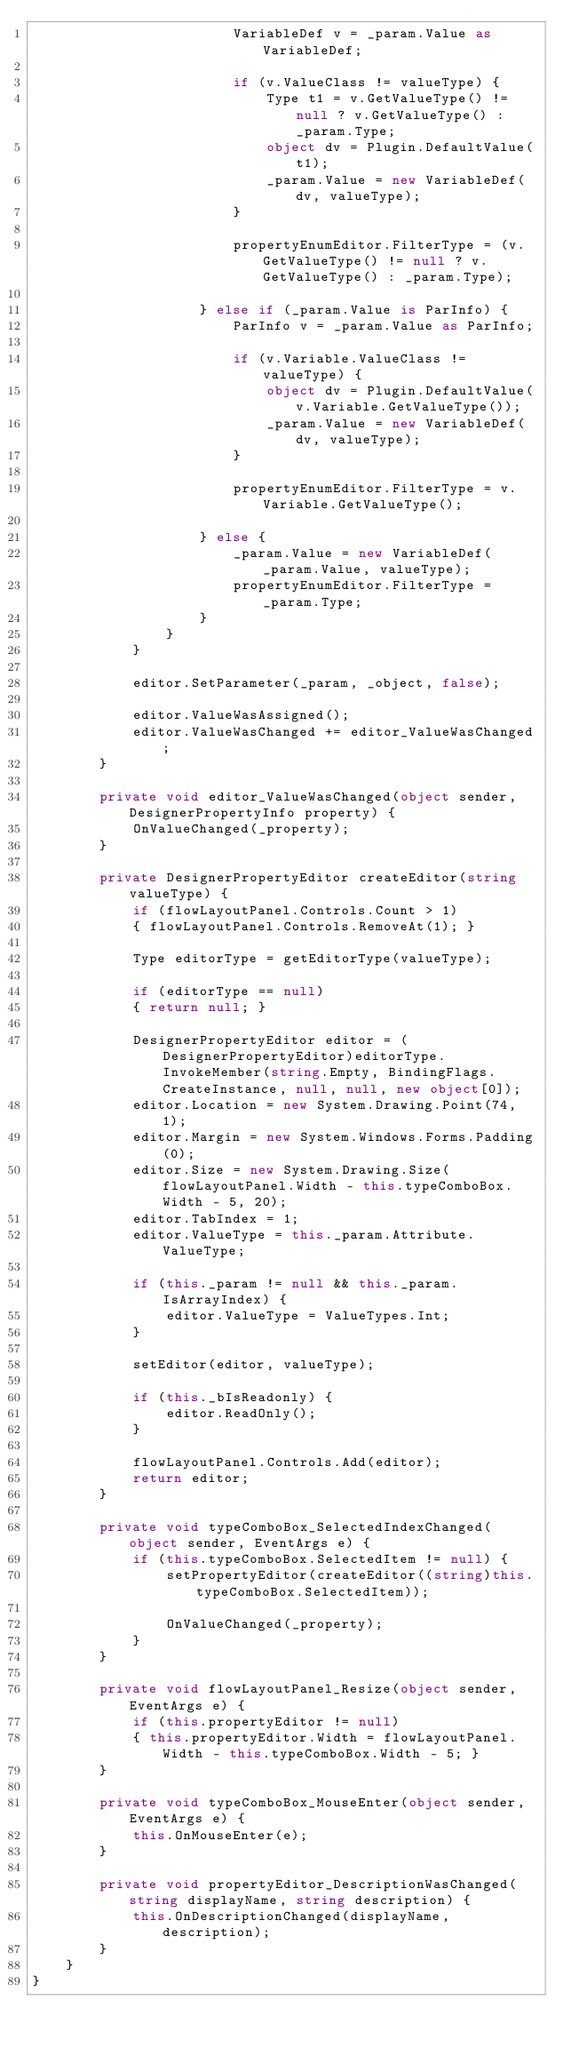<code> <loc_0><loc_0><loc_500><loc_500><_C#_>                        VariableDef v = _param.Value as VariableDef;

                        if (v.ValueClass != valueType) {
                            Type t1 = v.GetValueType() != null ? v.GetValueType() : _param.Type;
                            object dv = Plugin.DefaultValue(t1);
                            _param.Value = new VariableDef(dv, valueType);
                        }

                        propertyEnumEditor.FilterType = (v.GetValueType() != null ? v.GetValueType() : _param.Type);

                    } else if (_param.Value is ParInfo) {
                        ParInfo v = _param.Value as ParInfo;

                        if (v.Variable.ValueClass != valueType) {
                            object dv = Plugin.DefaultValue(v.Variable.GetValueType());
                            _param.Value = new VariableDef(dv, valueType);
                        }

                        propertyEnumEditor.FilterType = v.Variable.GetValueType();

                    } else {
                        _param.Value = new VariableDef(_param.Value, valueType);
                        propertyEnumEditor.FilterType = _param.Type;
                    }
                }
            }

            editor.SetParameter(_param, _object, false);

            editor.ValueWasAssigned();
            editor.ValueWasChanged += editor_ValueWasChanged;
        }

        private void editor_ValueWasChanged(object sender, DesignerPropertyInfo property) {
            OnValueChanged(_property);
        }

        private DesignerPropertyEditor createEditor(string valueType) {
            if (flowLayoutPanel.Controls.Count > 1)
            { flowLayoutPanel.Controls.RemoveAt(1); }

            Type editorType = getEditorType(valueType);

            if (editorType == null)
            { return null; }

            DesignerPropertyEditor editor = (DesignerPropertyEditor)editorType.InvokeMember(string.Empty, BindingFlags.CreateInstance, null, null, new object[0]);
            editor.Location = new System.Drawing.Point(74, 1);
            editor.Margin = new System.Windows.Forms.Padding(0);
            editor.Size = new System.Drawing.Size(flowLayoutPanel.Width - this.typeComboBox.Width - 5, 20);
            editor.TabIndex = 1;
            editor.ValueType = this._param.Attribute.ValueType;

            if (this._param != null && this._param.IsArrayIndex) {
                editor.ValueType = ValueTypes.Int;
            }

            setEditor(editor, valueType);

            if (this._bIsReadonly) {
                editor.ReadOnly();
            }

            flowLayoutPanel.Controls.Add(editor);
            return editor;
        }

        private void typeComboBox_SelectedIndexChanged(object sender, EventArgs e) {
            if (this.typeComboBox.SelectedItem != null) {
                setPropertyEditor(createEditor((string)this.typeComboBox.SelectedItem));

                OnValueChanged(_property);
            }
        }

        private void flowLayoutPanel_Resize(object sender, EventArgs e) {
            if (this.propertyEditor != null)
            { this.propertyEditor.Width = flowLayoutPanel.Width - this.typeComboBox.Width - 5; }
        }

        private void typeComboBox_MouseEnter(object sender, EventArgs e) {
            this.OnMouseEnter(e);
        }

        private void propertyEditor_DescriptionWasChanged(string displayName, string description) {
            this.OnDescriptionChanged(displayName, description);
        }
    }
}
</code> 